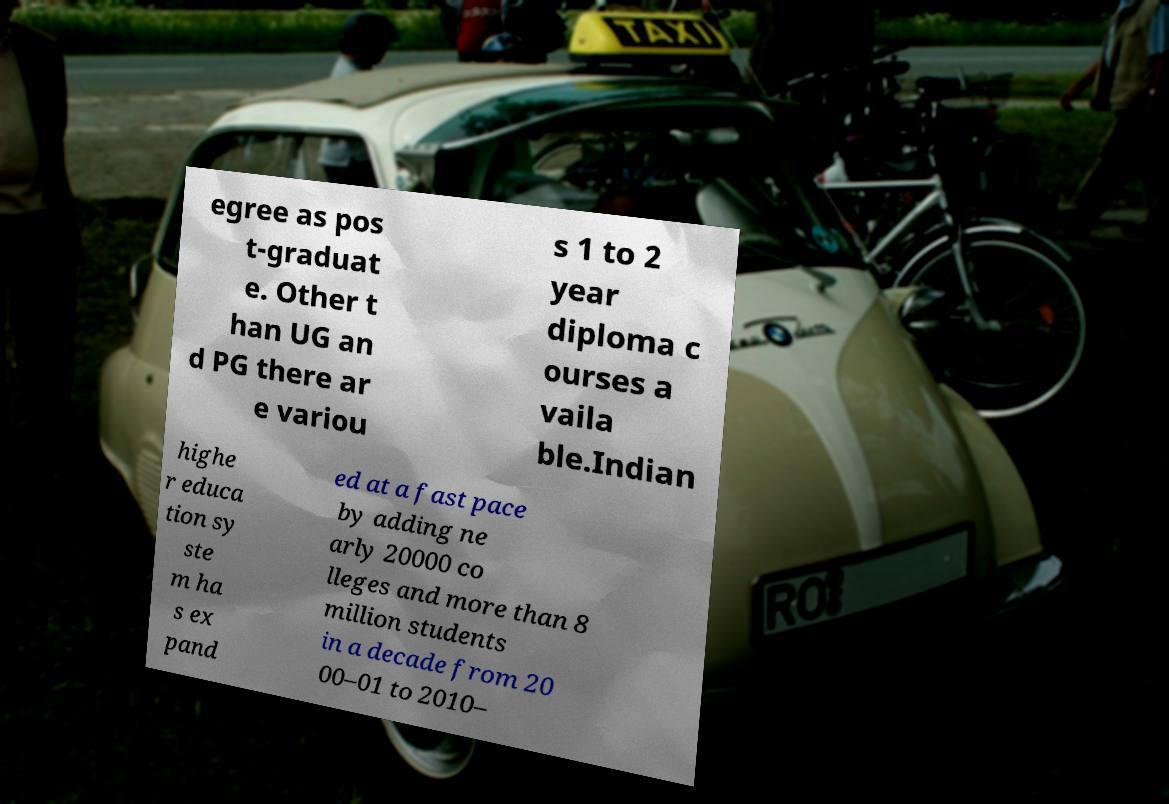Could you extract and type out the text from this image? egree as pos t-graduat e. Other t han UG an d PG there ar e variou s 1 to 2 year diploma c ourses a vaila ble.Indian highe r educa tion sy ste m ha s ex pand ed at a fast pace by adding ne arly 20000 co lleges and more than 8 million students in a decade from 20 00–01 to 2010– 